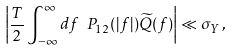<formula> <loc_0><loc_0><loc_500><loc_500>\left | \frac { T } { 2 } \int _ { - \infty } ^ { \infty } d f \ P _ { 1 2 } ( | f | ) \widetilde { Q } ( f ) \right | \ll \sigma _ { Y } \, ,</formula> 